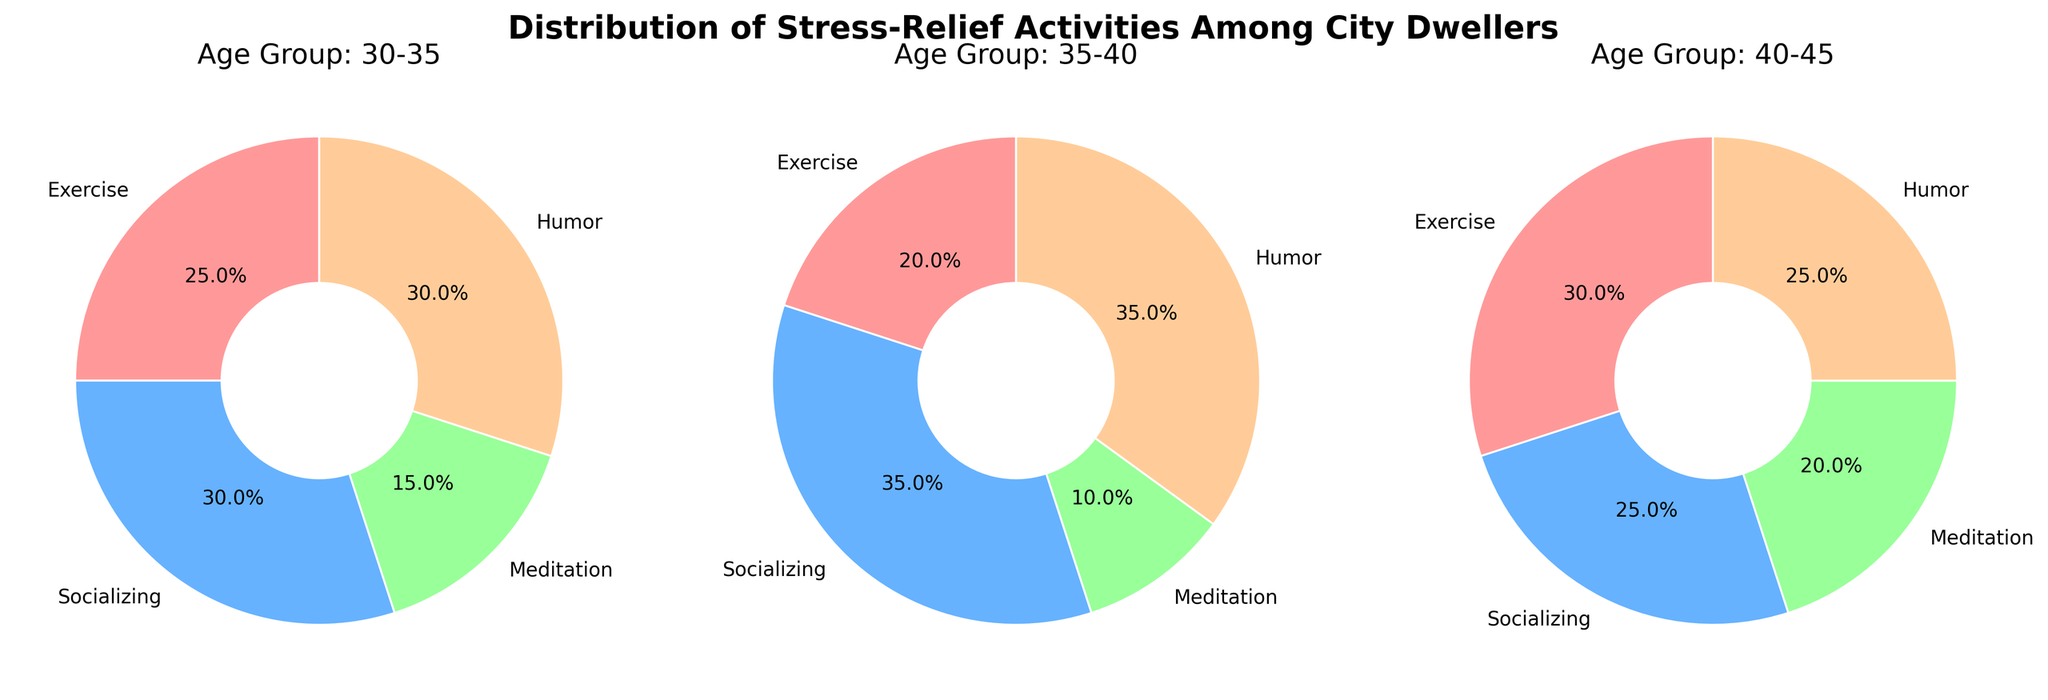What is the title of the figure? The title of the figure is displayed at the top of the plot in bold text.
Answer: Distribution of Stress-Relief Activities Among City Dwellers Which activity has the highest percentage for the 35-40 age group? In the pie chart for the 35-40 age group, the largest segment corresponds to the activity labeled "Humor," which has the highest percentage.
Answer: Humor What is the total percentage of Exercise and Meditation for the 40-45 age group? In the pie chart for the 40-45 age group, the percentages for Exercise and Meditation are 30% and 20%, respectively. Adding these together gives 30% + 20% = 50%.
Answer: 50% Which age group participates most in socializing? By comparing the pie charts, the 35-40 age group has the highest percentage for Socializing, which is 35%.
Answer: 35-40 What is the least common stress-relief activity for the 30-35 age group? In the pie chart for the 30-35 age group, Meditation has the smallest segment, indicating it is the least common activity with 15%.
Answer: Meditation How does the percentage of Humor in the 30-35 age group compare to that in the 40-45 age group? The percentage of Humor in the 30-35 age group is 30%, while in the 40-45 age group it is 25%. Therefore, Humor is 5% more common in the 30-35 age group.
Answer: Humor is 5% more common in the 30-35 age group Which age group has the highest percentage of Exercise? By observing the pie charts, the 40-45 age group has the highest percentage of exercise at 30%.
Answer: 40-45 Comparing the three age groups, which activity shows the most consistent participation level across all groups? By analyzing each pie chart, Exercise shows substantial variation (from 20% to 30%), Socializing ranges from 25% to 35%, Meditation ranges between 10% to 20%, and Humor ranges from 25% to 35%. Socializing and Humor are more consistent, but Socializing ranges slightly less, making it more consistent.
Answer: Socializing If you combine the percentages of Meditation across all age groups, what percentage of people meditate overall? Add the percentages of Meditation from each age group: 15% (30-35) + 10% (35-40) + 20% (40-45) = 45%.
Answer: 45% 